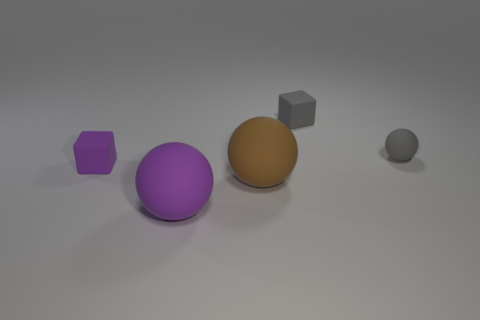There is a rubber cube that is left of the brown rubber ball; what is its size?
Provide a succinct answer. Small. What shape is the purple matte thing to the right of the purple matte thing that is behind the brown thing?
Your response must be concise. Sphere. There is a small gray rubber object right of the tiny block to the right of the purple block; what number of tiny gray rubber balls are right of it?
Offer a very short reply. 0. Are there fewer things behind the brown matte thing than large metallic blocks?
Offer a terse response. No. Is there any other thing that is the same shape as the brown rubber object?
Your response must be concise. Yes. There is a large rubber thing that is to the left of the brown thing; what is its shape?
Make the answer very short. Sphere. There is a tiny gray thing behind the gray thing that is in front of the gray cube that is behind the tiny gray ball; what shape is it?
Offer a very short reply. Cube. How many things are either tiny matte things or purple blocks?
Your response must be concise. 3. There is a tiny gray thing that is left of the gray sphere; is its shape the same as the matte thing left of the large purple matte thing?
Make the answer very short. Yes. What number of rubber things are both behind the small purple cube and to the left of the gray ball?
Keep it short and to the point. 1. 